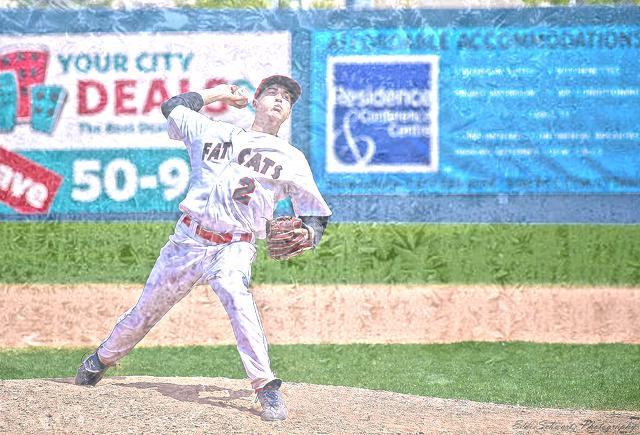What sport is being played in the image? The sport being played in the image is baseball, as indicated by the player's uniform and the baseball glove he's wearing. 